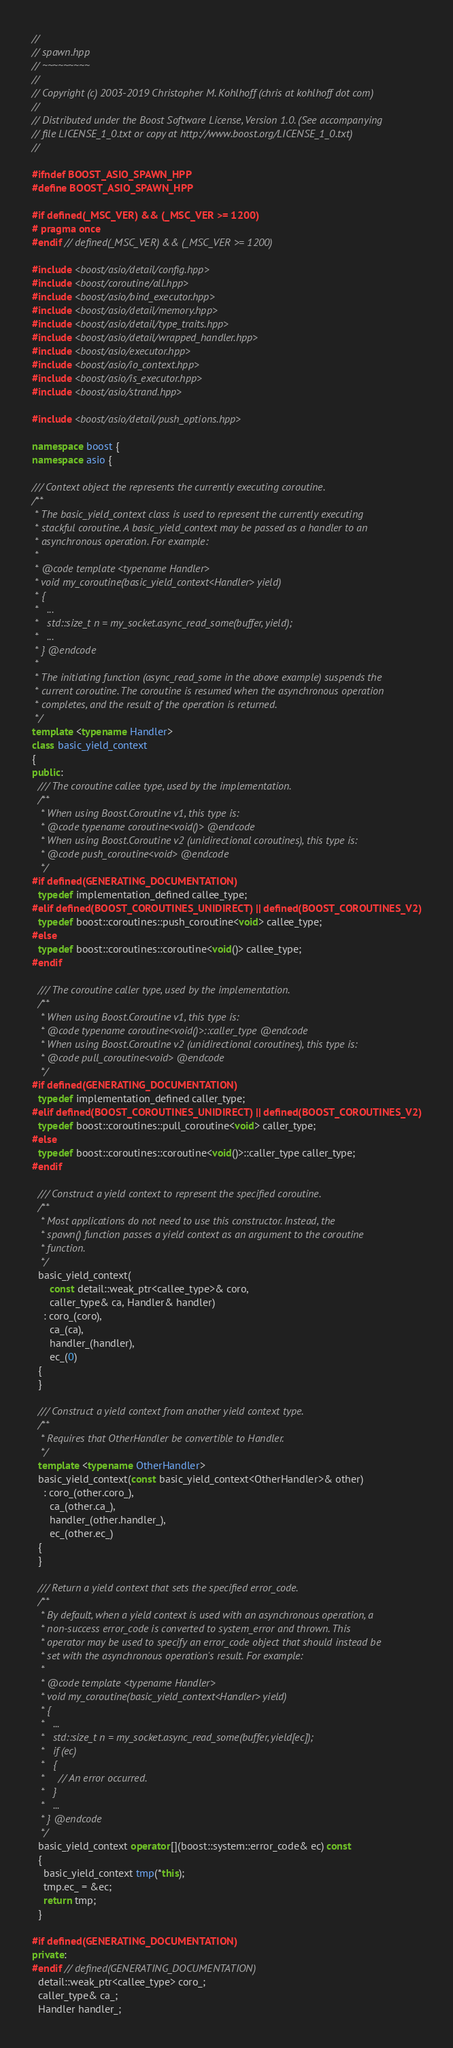Convert code to text. <code><loc_0><loc_0><loc_500><loc_500><_C++_>//
// spawn.hpp
// ~~~~~~~~~
//
// Copyright (c) 2003-2019 Christopher M. Kohlhoff (chris at kohlhoff dot com)
//
// Distributed under the Boost Software License, Version 1.0. (See accompanying
// file LICENSE_1_0.txt or copy at http://www.boost.org/LICENSE_1_0.txt)
//

#ifndef BOOST_ASIO_SPAWN_HPP
#define BOOST_ASIO_SPAWN_HPP

#if defined(_MSC_VER) && (_MSC_VER >= 1200)
# pragma once
#endif // defined(_MSC_VER) && (_MSC_VER >= 1200)

#include <boost/asio/detail/config.hpp>
#include <boost/coroutine/all.hpp>
#include <boost/asio/bind_executor.hpp>
#include <boost/asio/detail/memory.hpp>
#include <boost/asio/detail/type_traits.hpp>
#include <boost/asio/detail/wrapped_handler.hpp>
#include <boost/asio/executor.hpp>
#include <boost/asio/io_context.hpp>
#include <boost/asio/is_executor.hpp>
#include <boost/asio/strand.hpp>

#include <boost/asio/detail/push_options.hpp>

namespace boost {
namespace asio {

/// Context object the represents the currently executing coroutine.
/**
 * The basic_yield_context class is used to represent the currently executing
 * stackful coroutine. A basic_yield_context may be passed as a handler to an
 * asynchronous operation. For example:
 *
 * @code template <typename Handler>
 * void my_coroutine(basic_yield_context<Handler> yield)
 * {
 *   ...
 *   std::size_t n = my_socket.async_read_some(buffer, yield);
 *   ...
 * } @endcode
 *
 * The initiating function (async_read_some in the above example) suspends the
 * current coroutine. The coroutine is resumed when the asynchronous operation
 * completes, and the result of the operation is returned.
 */
template <typename Handler>
class basic_yield_context
{
public:
  /// The coroutine callee type, used by the implementation.
  /**
   * When using Boost.Coroutine v1, this type is:
   * @code typename coroutine<void()> @endcode
   * When using Boost.Coroutine v2 (unidirectional coroutines), this type is:
   * @code push_coroutine<void> @endcode
   */
#if defined(GENERATING_DOCUMENTATION)
  typedef implementation_defined callee_type;
#elif defined(BOOST_COROUTINES_UNIDIRECT) || defined(BOOST_COROUTINES_V2)
  typedef boost::coroutines::push_coroutine<void> callee_type;
#else
  typedef boost::coroutines::coroutine<void()> callee_type;
#endif
  
  /// The coroutine caller type, used by the implementation.
  /**
   * When using Boost.Coroutine v1, this type is:
   * @code typename coroutine<void()>::caller_type @endcode
   * When using Boost.Coroutine v2 (unidirectional coroutines), this type is:
   * @code pull_coroutine<void> @endcode
   */
#if defined(GENERATING_DOCUMENTATION)
  typedef implementation_defined caller_type;
#elif defined(BOOST_COROUTINES_UNIDIRECT) || defined(BOOST_COROUTINES_V2)
  typedef boost::coroutines::pull_coroutine<void> caller_type;
#else
  typedef boost::coroutines::coroutine<void()>::caller_type caller_type;
#endif

  /// Construct a yield context to represent the specified coroutine.
  /**
   * Most applications do not need to use this constructor. Instead, the
   * spawn() function passes a yield context as an argument to the coroutine
   * function.
   */
  basic_yield_context(
      const detail::weak_ptr<callee_type>& coro,
      caller_type& ca, Handler& handler)
    : coro_(coro),
      ca_(ca),
      handler_(handler),
      ec_(0)
  {
  }

  /// Construct a yield context from another yield context type.
  /**
   * Requires that OtherHandler be convertible to Handler.
   */
  template <typename OtherHandler>
  basic_yield_context(const basic_yield_context<OtherHandler>& other)
    : coro_(other.coro_),
      ca_(other.ca_),
      handler_(other.handler_),
      ec_(other.ec_)
  {
  }

  /// Return a yield context that sets the specified error_code.
  /**
   * By default, when a yield context is used with an asynchronous operation, a
   * non-success error_code is converted to system_error and thrown. This
   * operator may be used to specify an error_code object that should instead be
   * set with the asynchronous operation's result. For example:
   *
   * @code template <typename Handler>
   * void my_coroutine(basic_yield_context<Handler> yield)
   * {
   *   ...
   *   std::size_t n = my_socket.async_read_some(buffer, yield[ec]);
   *   if (ec)
   *   {
   *     // An error occurred.
   *   }
   *   ...
   * } @endcode
   */
  basic_yield_context operator[](boost::system::error_code& ec) const
  {
    basic_yield_context tmp(*this);
    tmp.ec_ = &ec;
    return tmp;
  }

#if defined(GENERATING_DOCUMENTATION)
private:
#endif // defined(GENERATING_DOCUMENTATION)
  detail::weak_ptr<callee_type> coro_;
  caller_type& ca_;
  Handler handler_;</code> 